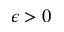Convert formula to latex. <formula><loc_0><loc_0><loc_500><loc_500>\epsilon > 0</formula> 